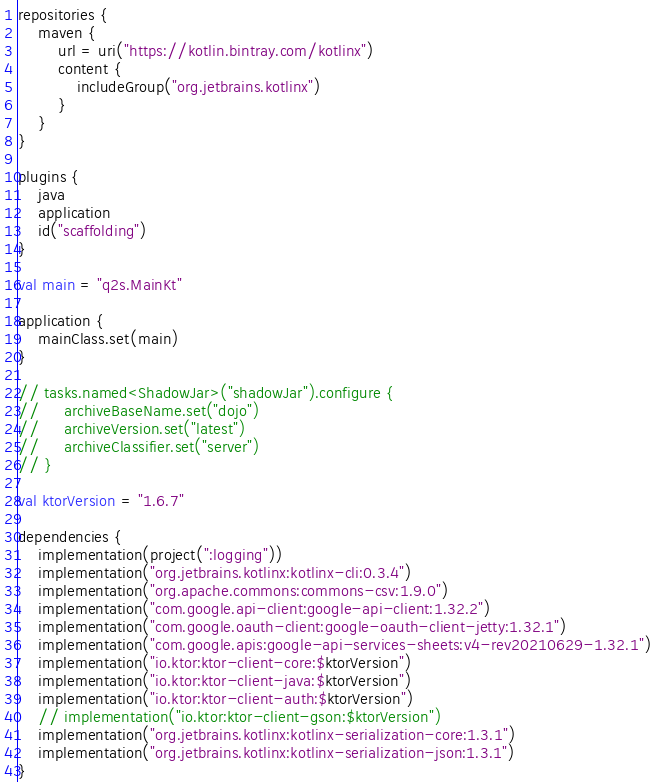Convert code to text. <code><loc_0><loc_0><loc_500><loc_500><_Kotlin_>repositories {
    maven {
        url = uri("https://kotlin.bintray.com/kotlinx")
        content {
            includeGroup("org.jetbrains.kotlinx")
        }
    }
}

plugins {
    java
    application
    id("scaffolding")
}

val main = "q2s.MainKt"

application {
    mainClass.set(main)
}

// tasks.named<ShadowJar>("shadowJar").configure {
//     archiveBaseName.set("dojo")
//     archiveVersion.set("latest")
//     archiveClassifier.set("server")
// }

val ktorVersion = "1.6.7"

dependencies {
    implementation(project(":logging"))
    implementation("org.jetbrains.kotlinx:kotlinx-cli:0.3.4")
    implementation("org.apache.commons:commons-csv:1.9.0")
    implementation("com.google.api-client:google-api-client:1.32.2")
    implementation("com.google.oauth-client:google-oauth-client-jetty:1.32.1")
    implementation("com.google.apis:google-api-services-sheets:v4-rev20210629-1.32.1")
    implementation("io.ktor:ktor-client-core:$ktorVersion")
    implementation("io.ktor:ktor-client-java:$ktorVersion")
    implementation("io.ktor:ktor-client-auth:$ktorVersion")
    // implementation("io.ktor:ktor-client-gson:$ktorVersion")
    implementation("org.jetbrains.kotlinx:kotlinx-serialization-core:1.3.1")
    implementation("org.jetbrains.kotlinx:kotlinx-serialization-json:1.3.1")
}
</code> 